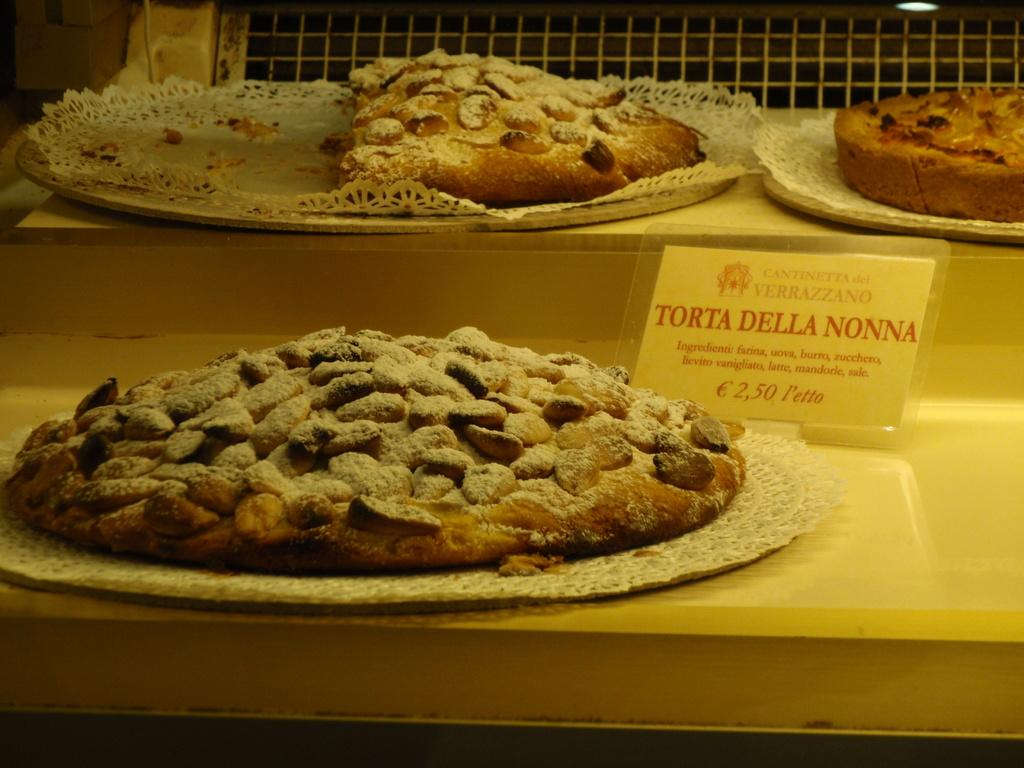What type of food can be seen on the plates in the image? There are baked items on plates in the image. Where are the plates located? The plates are placed on a surface. Is there any information about the cost of the items in the image? Yes, there is a price card present on the right side of the image. How many corks are visible in the image? There are no corks present in the image. Are there any girls visible in the image? There is no mention of girls in the provided facts, so we cannot determine if any are present in the image. 